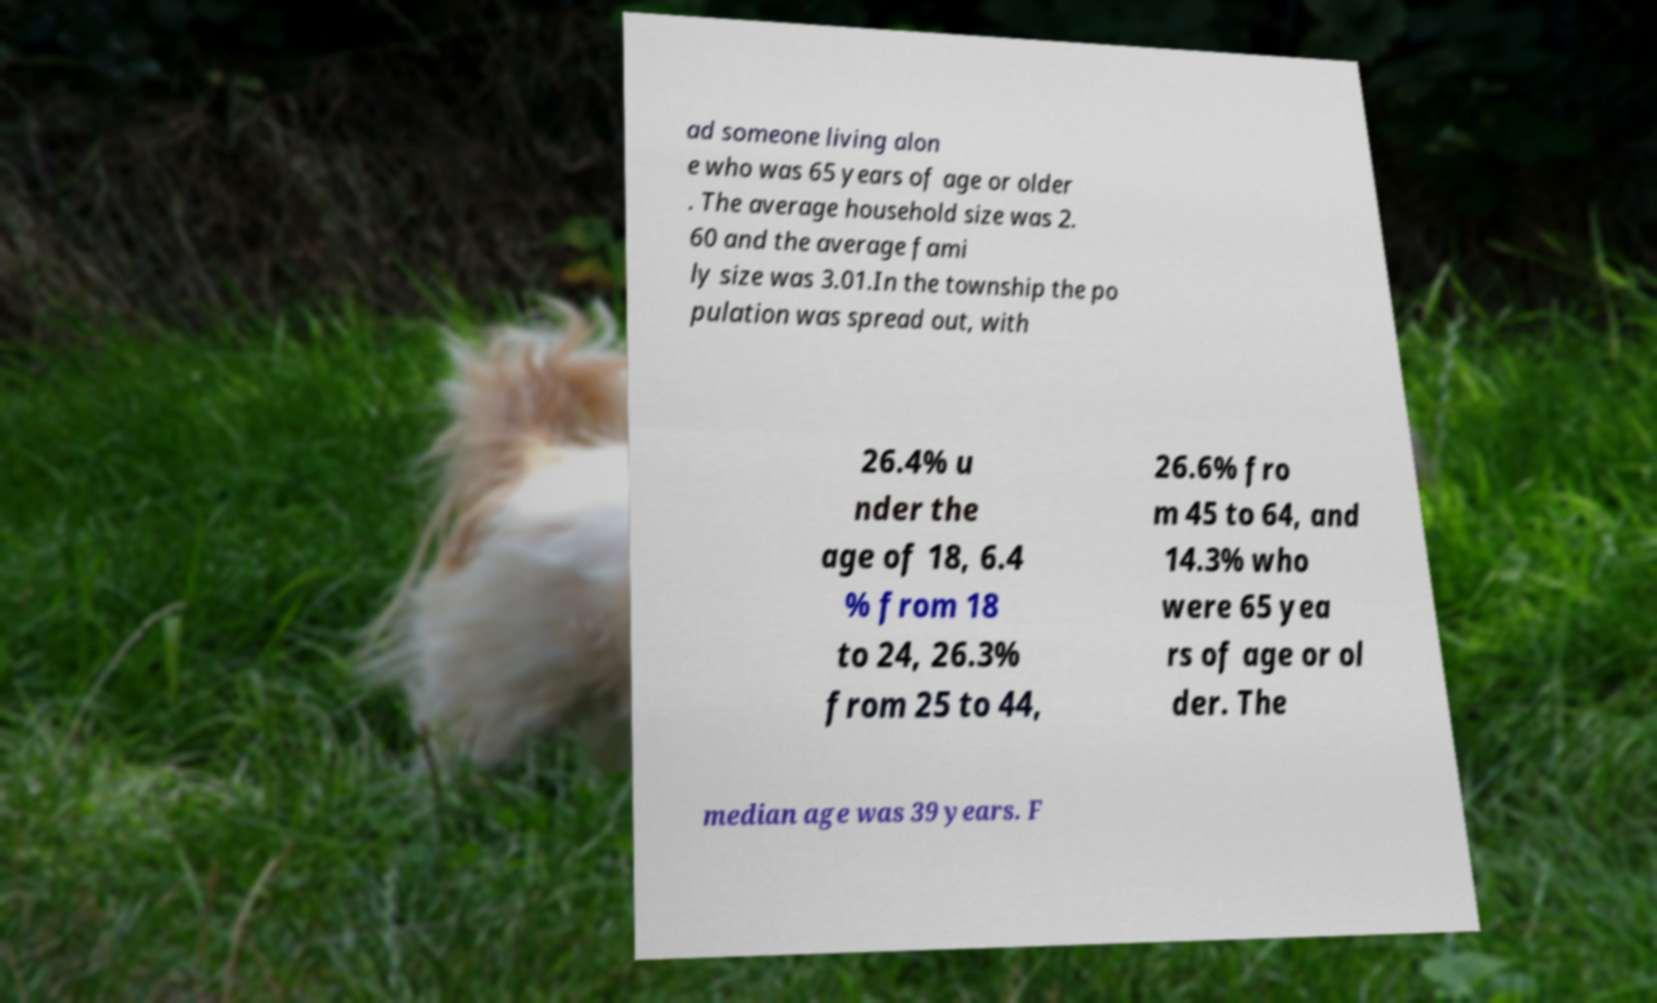What messages or text are displayed in this image? I need them in a readable, typed format. ad someone living alon e who was 65 years of age or older . The average household size was 2. 60 and the average fami ly size was 3.01.In the township the po pulation was spread out, with 26.4% u nder the age of 18, 6.4 % from 18 to 24, 26.3% from 25 to 44, 26.6% fro m 45 to 64, and 14.3% who were 65 yea rs of age or ol der. The median age was 39 years. F 